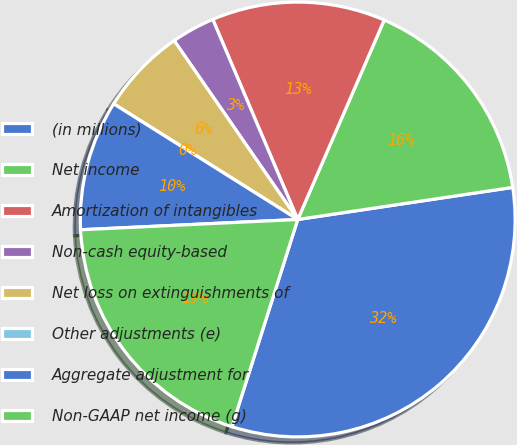<chart> <loc_0><loc_0><loc_500><loc_500><pie_chart><fcel>(in millions)<fcel>Net income<fcel>Amortization of intangibles<fcel>Non-cash equity-based<fcel>Net loss on extinguishments of<fcel>Other adjustments (e)<fcel>Aggregate adjustment for<fcel>Non-GAAP net income (g)<nl><fcel>32.25%<fcel>16.13%<fcel>12.9%<fcel>3.23%<fcel>6.45%<fcel>0.0%<fcel>9.68%<fcel>19.35%<nl></chart> 